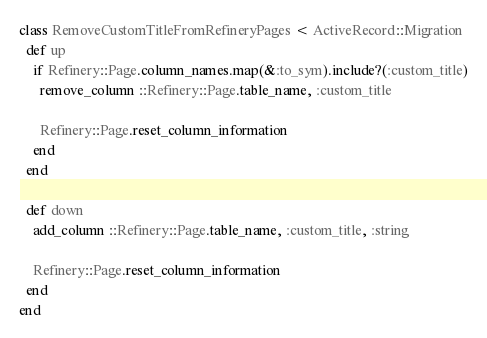Convert code to text. <code><loc_0><loc_0><loc_500><loc_500><_Ruby_>class RemoveCustomTitleFromRefineryPages < ActiveRecord::Migration
  def up
    if Refinery::Page.column_names.map(&:to_sym).include?(:custom_title)
      remove_column ::Refinery::Page.table_name, :custom_title

      Refinery::Page.reset_column_information
    end
  end

  def down
    add_column ::Refinery::Page.table_name, :custom_title, :string

    Refinery::Page.reset_column_information
  end
end
</code> 